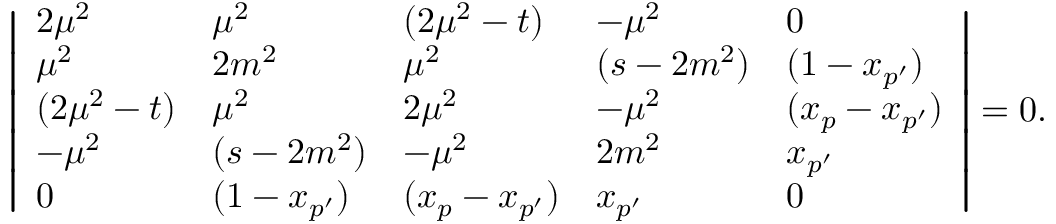Convert formula to latex. <formula><loc_0><loc_0><loc_500><loc_500>\left | \begin{array} { l l l l l } { { 2 \mu ^ { 2 } } } & { { \mu ^ { 2 } } } & { { ( 2 \mu ^ { 2 } - t ) } } & { { - \mu ^ { 2 } } } & { 0 } \\ { { \mu ^ { 2 } } } & { { 2 m ^ { 2 } } } & { { \mu ^ { 2 } } } & { { ( s - 2 m ^ { 2 } ) } } & { { ( 1 - x _ { p ^ { \prime } } ) } } \\ { { ( 2 \mu ^ { 2 } - t ) } } & { { \mu ^ { 2 } } } & { { 2 \mu ^ { 2 } } } & { { - \mu ^ { 2 } } } & { { ( x _ { p } - x _ { p ^ { \prime } } ) } } \\ { { - \mu ^ { 2 } } } & { { ( s - 2 m ^ { 2 } ) } } & { { - \mu ^ { 2 } } } & { { 2 m ^ { 2 } } } & { { x _ { p ^ { \prime } } } } \\ { 0 } & { { ( 1 - x _ { p ^ { \prime } } ) } } & { { ( x _ { p } - x _ { p ^ { \prime } } ) } } & { { x _ { p ^ { \prime } } } } & { 0 } \end{array} \right | = 0 .</formula> 